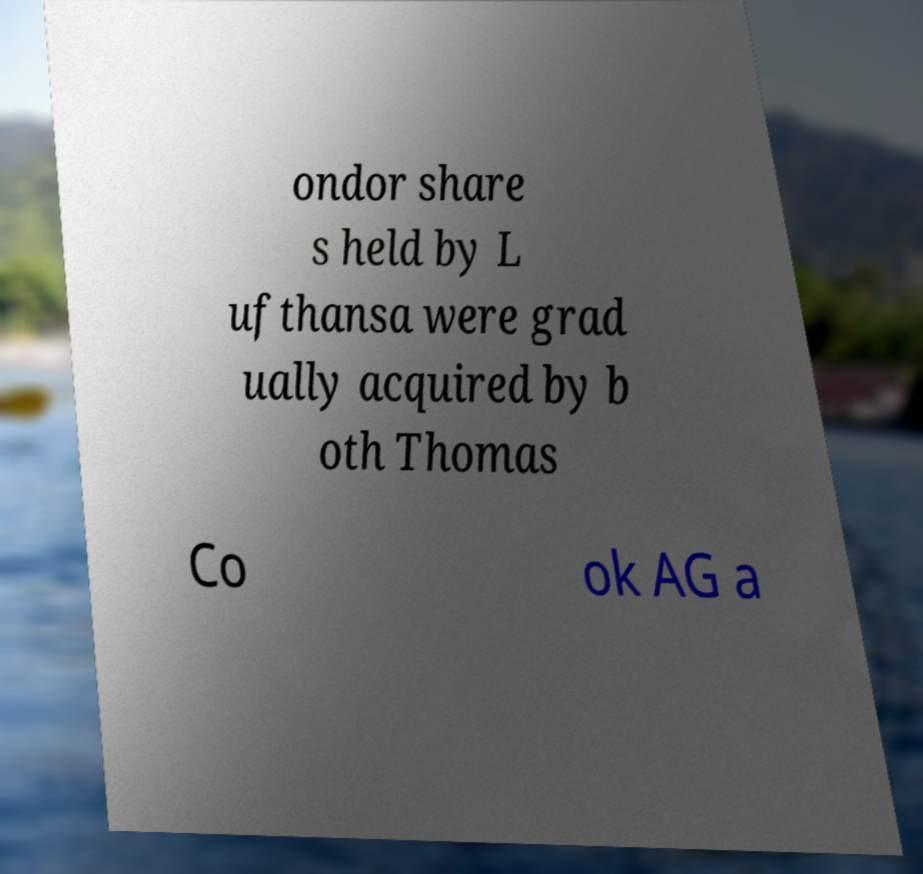Could you assist in decoding the text presented in this image and type it out clearly? ondor share s held by L ufthansa were grad ually acquired by b oth Thomas Co ok AG a 